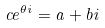<formula> <loc_0><loc_0><loc_500><loc_500>c e ^ { \theta i } = a + b i</formula> 